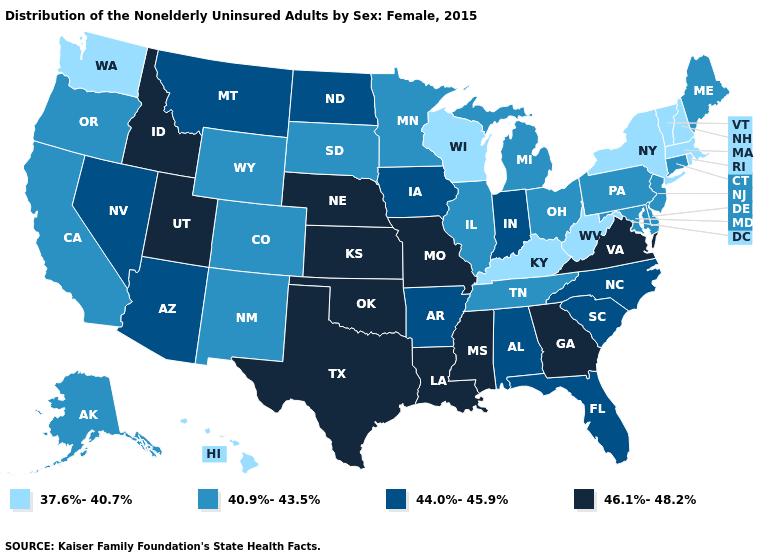Name the states that have a value in the range 40.9%-43.5%?
Concise answer only. Alaska, California, Colorado, Connecticut, Delaware, Illinois, Maine, Maryland, Michigan, Minnesota, New Jersey, New Mexico, Ohio, Oregon, Pennsylvania, South Dakota, Tennessee, Wyoming. Which states have the highest value in the USA?
Write a very short answer. Georgia, Idaho, Kansas, Louisiana, Mississippi, Missouri, Nebraska, Oklahoma, Texas, Utah, Virginia. Name the states that have a value in the range 37.6%-40.7%?
Give a very brief answer. Hawaii, Kentucky, Massachusetts, New Hampshire, New York, Rhode Island, Vermont, Washington, West Virginia, Wisconsin. How many symbols are there in the legend?
Write a very short answer. 4. Does Connecticut have a lower value than Utah?
Concise answer only. Yes. Among the states that border Washington , which have the lowest value?
Short answer required. Oregon. What is the value of Alaska?
Be succinct. 40.9%-43.5%. Does the first symbol in the legend represent the smallest category?
Concise answer only. Yes. What is the value of New Jersey?
Write a very short answer. 40.9%-43.5%. What is the lowest value in the USA?
Keep it brief. 37.6%-40.7%. Does Montana have the highest value in the West?
Give a very brief answer. No. How many symbols are there in the legend?
Concise answer only. 4. What is the value of Louisiana?
Concise answer only. 46.1%-48.2%. Which states have the lowest value in the USA?
Concise answer only. Hawaii, Kentucky, Massachusetts, New Hampshire, New York, Rhode Island, Vermont, Washington, West Virginia, Wisconsin. Name the states that have a value in the range 46.1%-48.2%?
Short answer required. Georgia, Idaho, Kansas, Louisiana, Mississippi, Missouri, Nebraska, Oklahoma, Texas, Utah, Virginia. 